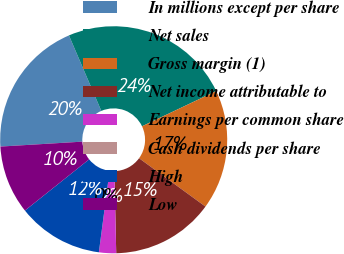Convert chart to OTSL. <chart><loc_0><loc_0><loc_500><loc_500><pie_chart><fcel>In millions except per share<fcel>Net sales<fcel>Gross margin (1)<fcel>Net income attributable to<fcel>Earnings per common share<fcel>Cash dividends per share<fcel>High<fcel>Low<nl><fcel>19.51%<fcel>24.39%<fcel>17.07%<fcel>14.63%<fcel>2.44%<fcel>0.0%<fcel>12.2%<fcel>9.76%<nl></chart> 